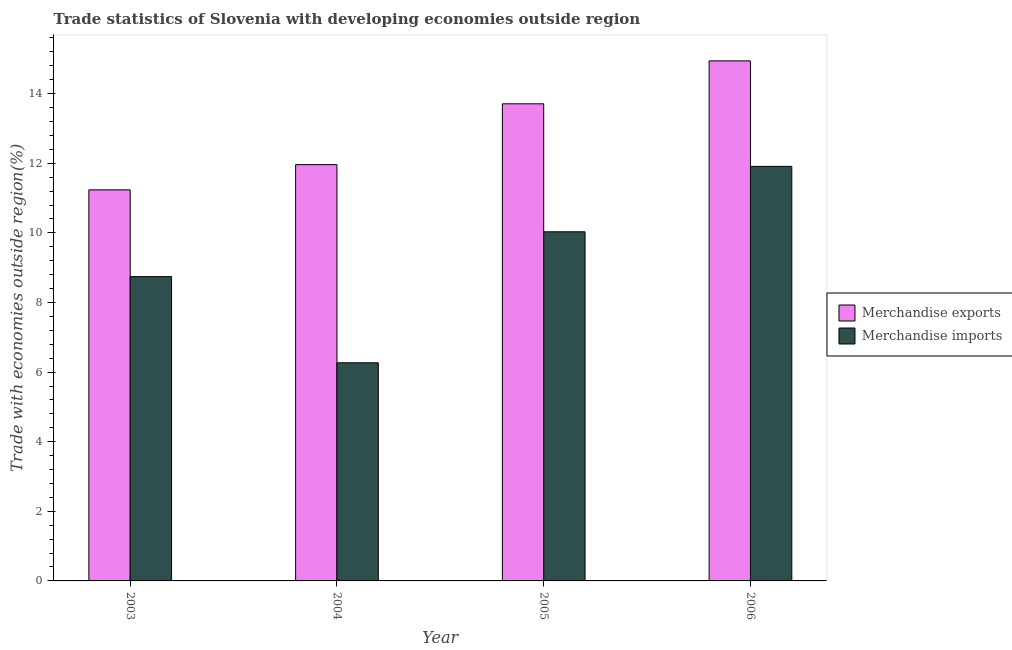How many different coloured bars are there?
Provide a succinct answer. 2. Are the number of bars on each tick of the X-axis equal?
Keep it short and to the point. Yes. How many bars are there on the 3rd tick from the right?
Keep it short and to the point. 2. What is the label of the 3rd group of bars from the left?
Offer a very short reply. 2005. What is the merchandise exports in 2003?
Your answer should be very brief. 11.24. Across all years, what is the maximum merchandise exports?
Your answer should be very brief. 14.94. Across all years, what is the minimum merchandise imports?
Ensure brevity in your answer.  6.27. What is the total merchandise exports in the graph?
Your answer should be very brief. 51.85. What is the difference between the merchandise exports in 2003 and that in 2004?
Keep it short and to the point. -0.72. What is the difference between the merchandise imports in 2003 and the merchandise exports in 2006?
Provide a short and direct response. -3.17. What is the average merchandise exports per year?
Offer a terse response. 12.96. In the year 2006, what is the difference between the merchandise imports and merchandise exports?
Ensure brevity in your answer.  0. In how many years, is the merchandise imports greater than 3.2 %?
Keep it short and to the point. 4. What is the ratio of the merchandise exports in 2004 to that in 2006?
Your response must be concise. 0.8. Is the merchandise imports in 2003 less than that in 2005?
Offer a terse response. Yes. Is the difference between the merchandise exports in 2005 and 2006 greater than the difference between the merchandise imports in 2005 and 2006?
Your answer should be very brief. No. What is the difference between the highest and the second highest merchandise exports?
Provide a succinct answer. 1.23. What is the difference between the highest and the lowest merchandise imports?
Ensure brevity in your answer.  5.64. Is the sum of the merchandise exports in 2004 and 2006 greater than the maximum merchandise imports across all years?
Offer a very short reply. Yes. What does the 1st bar from the right in 2004 represents?
Keep it short and to the point. Merchandise imports. What is the difference between two consecutive major ticks on the Y-axis?
Provide a short and direct response. 2. Does the graph contain any zero values?
Your response must be concise. No. Does the graph contain grids?
Provide a succinct answer. No. How many legend labels are there?
Ensure brevity in your answer.  2. How are the legend labels stacked?
Your answer should be very brief. Vertical. What is the title of the graph?
Your response must be concise. Trade statistics of Slovenia with developing economies outside region. Does "Male labourers" appear as one of the legend labels in the graph?
Your response must be concise. No. What is the label or title of the X-axis?
Your answer should be very brief. Year. What is the label or title of the Y-axis?
Give a very brief answer. Trade with economies outside region(%). What is the Trade with economies outside region(%) of Merchandise exports in 2003?
Ensure brevity in your answer.  11.24. What is the Trade with economies outside region(%) in Merchandise imports in 2003?
Ensure brevity in your answer.  8.74. What is the Trade with economies outside region(%) in Merchandise exports in 2004?
Offer a terse response. 11.96. What is the Trade with economies outside region(%) in Merchandise imports in 2004?
Offer a terse response. 6.27. What is the Trade with economies outside region(%) of Merchandise exports in 2005?
Your answer should be compact. 13.71. What is the Trade with economies outside region(%) in Merchandise imports in 2005?
Provide a succinct answer. 10.03. What is the Trade with economies outside region(%) of Merchandise exports in 2006?
Ensure brevity in your answer.  14.94. What is the Trade with economies outside region(%) of Merchandise imports in 2006?
Offer a very short reply. 11.91. Across all years, what is the maximum Trade with economies outside region(%) in Merchandise exports?
Your answer should be compact. 14.94. Across all years, what is the maximum Trade with economies outside region(%) of Merchandise imports?
Make the answer very short. 11.91. Across all years, what is the minimum Trade with economies outside region(%) in Merchandise exports?
Your answer should be compact. 11.24. Across all years, what is the minimum Trade with economies outside region(%) in Merchandise imports?
Offer a terse response. 6.27. What is the total Trade with economies outside region(%) in Merchandise exports in the graph?
Offer a very short reply. 51.85. What is the total Trade with economies outside region(%) in Merchandise imports in the graph?
Offer a very short reply. 36.95. What is the difference between the Trade with economies outside region(%) of Merchandise exports in 2003 and that in 2004?
Ensure brevity in your answer.  -0.72. What is the difference between the Trade with economies outside region(%) in Merchandise imports in 2003 and that in 2004?
Keep it short and to the point. 2.48. What is the difference between the Trade with economies outside region(%) of Merchandise exports in 2003 and that in 2005?
Offer a terse response. -2.47. What is the difference between the Trade with economies outside region(%) in Merchandise imports in 2003 and that in 2005?
Offer a terse response. -1.29. What is the difference between the Trade with economies outside region(%) of Merchandise exports in 2003 and that in 2006?
Offer a terse response. -3.71. What is the difference between the Trade with economies outside region(%) of Merchandise imports in 2003 and that in 2006?
Provide a succinct answer. -3.17. What is the difference between the Trade with economies outside region(%) of Merchandise exports in 2004 and that in 2005?
Offer a very short reply. -1.75. What is the difference between the Trade with economies outside region(%) of Merchandise imports in 2004 and that in 2005?
Make the answer very short. -3.76. What is the difference between the Trade with economies outside region(%) in Merchandise exports in 2004 and that in 2006?
Your answer should be very brief. -2.98. What is the difference between the Trade with economies outside region(%) in Merchandise imports in 2004 and that in 2006?
Provide a succinct answer. -5.64. What is the difference between the Trade with economies outside region(%) in Merchandise exports in 2005 and that in 2006?
Offer a very short reply. -1.23. What is the difference between the Trade with economies outside region(%) in Merchandise imports in 2005 and that in 2006?
Your answer should be compact. -1.88. What is the difference between the Trade with economies outside region(%) of Merchandise exports in 2003 and the Trade with economies outside region(%) of Merchandise imports in 2004?
Your response must be concise. 4.97. What is the difference between the Trade with economies outside region(%) in Merchandise exports in 2003 and the Trade with economies outside region(%) in Merchandise imports in 2005?
Your answer should be very brief. 1.21. What is the difference between the Trade with economies outside region(%) in Merchandise exports in 2003 and the Trade with economies outside region(%) in Merchandise imports in 2006?
Ensure brevity in your answer.  -0.67. What is the difference between the Trade with economies outside region(%) in Merchandise exports in 2004 and the Trade with economies outside region(%) in Merchandise imports in 2005?
Provide a short and direct response. 1.93. What is the difference between the Trade with economies outside region(%) of Merchandise exports in 2004 and the Trade with economies outside region(%) of Merchandise imports in 2006?
Provide a short and direct response. 0.05. What is the difference between the Trade with economies outside region(%) of Merchandise exports in 2005 and the Trade with economies outside region(%) of Merchandise imports in 2006?
Keep it short and to the point. 1.8. What is the average Trade with economies outside region(%) of Merchandise exports per year?
Offer a terse response. 12.96. What is the average Trade with economies outside region(%) in Merchandise imports per year?
Keep it short and to the point. 9.24. In the year 2003, what is the difference between the Trade with economies outside region(%) of Merchandise exports and Trade with economies outside region(%) of Merchandise imports?
Keep it short and to the point. 2.49. In the year 2004, what is the difference between the Trade with economies outside region(%) of Merchandise exports and Trade with economies outside region(%) of Merchandise imports?
Keep it short and to the point. 5.69. In the year 2005, what is the difference between the Trade with economies outside region(%) of Merchandise exports and Trade with economies outside region(%) of Merchandise imports?
Make the answer very short. 3.68. In the year 2006, what is the difference between the Trade with economies outside region(%) of Merchandise exports and Trade with economies outside region(%) of Merchandise imports?
Make the answer very short. 3.03. What is the ratio of the Trade with economies outside region(%) of Merchandise exports in 2003 to that in 2004?
Keep it short and to the point. 0.94. What is the ratio of the Trade with economies outside region(%) of Merchandise imports in 2003 to that in 2004?
Your response must be concise. 1.4. What is the ratio of the Trade with economies outside region(%) in Merchandise exports in 2003 to that in 2005?
Your answer should be very brief. 0.82. What is the ratio of the Trade with economies outside region(%) of Merchandise imports in 2003 to that in 2005?
Your response must be concise. 0.87. What is the ratio of the Trade with economies outside region(%) of Merchandise exports in 2003 to that in 2006?
Provide a short and direct response. 0.75. What is the ratio of the Trade with economies outside region(%) in Merchandise imports in 2003 to that in 2006?
Your answer should be compact. 0.73. What is the ratio of the Trade with economies outside region(%) in Merchandise exports in 2004 to that in 2005?
Offer a terse response. 0.87. What is the ratio of the Trade with economies outside region(%) of Merchandise imports in 2004 to that in 2005?
Make the answer very short. 0.62. What is the ratio of the Trade with economies outside region(%) of Merchandise exports in 2004 to that in 2006?
Ensure brevity in your answer.  0.8. What is the ratio of the Trade with economies outside region(%) in Merchandise imports in 2004 to that in 2006?
Provide a succinct answer. 0.53. What is the ratio of the Trade with economies outside region(%) of Merchandise exports in 2005 to that in 2006?
Offer a terse response. 0.92. What is the ratio of the Trade with economies outside region(%) in Merchandise imports in 2005 to that in 2006?
Ensure brevity in your answer.  0.84. What is the difference between the highest and the second highest Trade with economies outside region(%) of Merchandise exports?
Your response must be concise. 1.23. What is the difference between the highest and the second highest Trade with economies outside region(%) in Merchandise imports?
Your answer should be very brief. 1.88. What is the difference between the highest and the lowest Trade with economies outside region(%) in Merchandise exports?
Ensure brevity in your answer.  3.71. What is the difference between the highest and the lowest Trade with economies outside region(%) in Merchandise imports?
Your answer should be very brief. 5.64. 